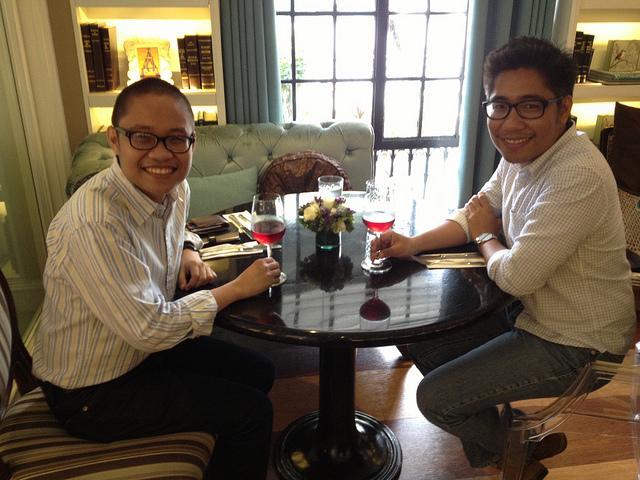Are these people at home?
Answer briefly. Yes. What color is the liquid in the glass?
Write a very short answer. Red. How many people are wearing glasses?
Quick response, please. 2. 